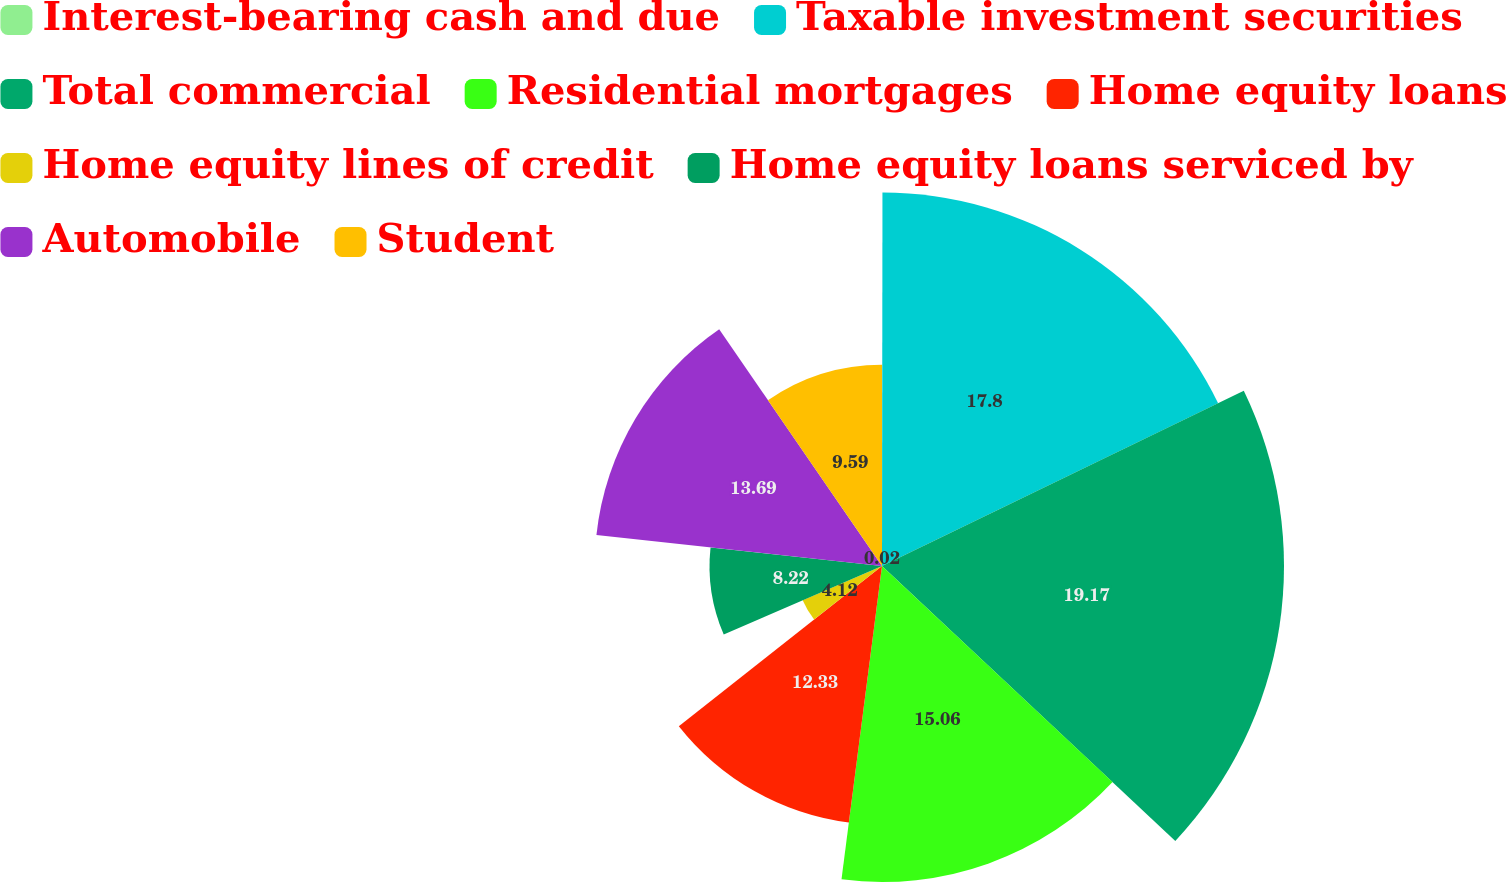Convert chart. <chart><loc_0><loc_0><loc_500><loc_500><pie_chart><fcel>Interest-bearing cash and due<fcel>Taxable investment securities<fcel>Total commercial<fcel>Residential mortgages<fcel>Home equity loans<fcel>Home equity lines of credit<fcel>Home equity loans serviced by<fcel>Automobile<fcel>Student<nl><fcel>0.02%<fcel>17.8%<fcel>19.16%<fcel>15.06%<fcel>12.33%<fcel>4.12%<fcel>8.22%<fcel>13.69%<fcel>9.59%<nl></chart> 